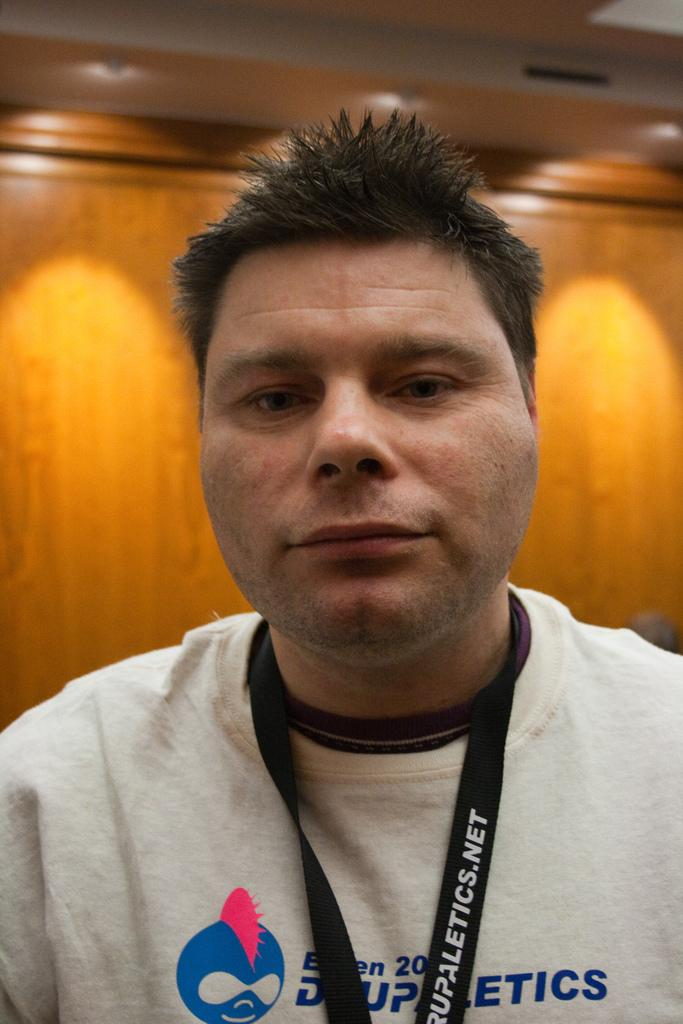<image>
Give a short and clear explanation of the subsequent image. A man poses with a lanyard from drupaletics.net. 